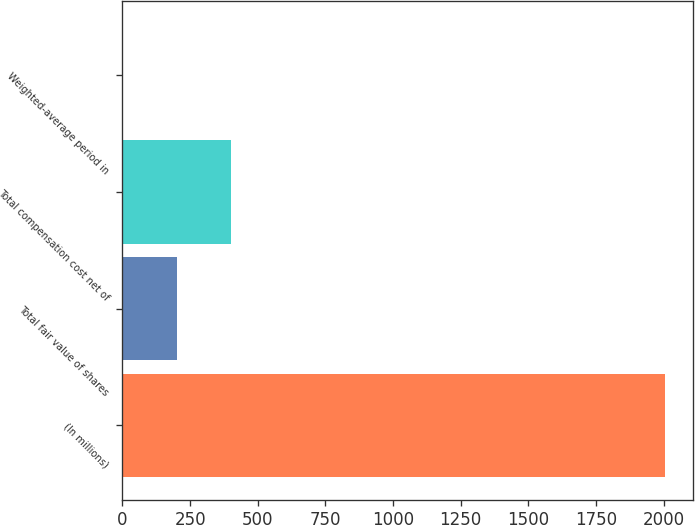Convert chart. <chart><loc_0><loc_0><loc_500><loc_500><bar_chart><fcel>(In millions)<fcel>Total fair value of shares<fcel>Total compensation cost net of<fcel>Weighted-average period in<nl><fcel>2007<fcel>202.5<fcel>403<fcel>2<nl></chart> 